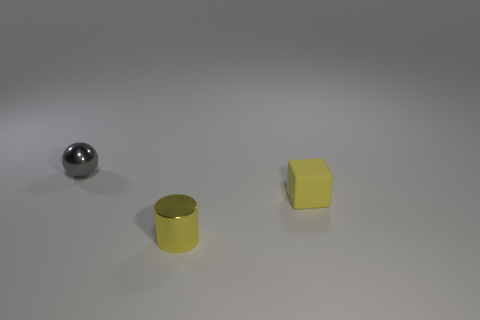There is a object that is on the right side of the tiny yellow shiny cylinder; does it have the same color as the cylinder?
Your answer should be compact. Yes. There is a tiny thing behind the matte object; what is its color?
Your answer should be very brief. Gray. Are there fewer small gray things that are right of the yellow rubber block than tiny gray metal things?
Offer a terse response. Yes. Is the gray object made of the same material as the yellow cube?
Give a very brief answer. No. How many things are either tiny objects in front of the small gray object or gray objects that are to the left of the small yellow cube?
Give a very brief answer. 3. Are there any purple metallic objects of the same size as the rubber thing?
Provide a succinct answer. No. There is a tiny metal object that is in front of the tiny gray ball; are there any small rubber objects behind it?
Your answer should be compact. Yes. Does the metallic thing behind the yellow cube have the same shape as the yellow matte object?
Offer a very short reply. No. What shape is the small yellow matte object?
Provide a short and direct response. Cube. What number of yellow cylinders are the same material as the gray ball?
Keep it short and to the point. 1. 